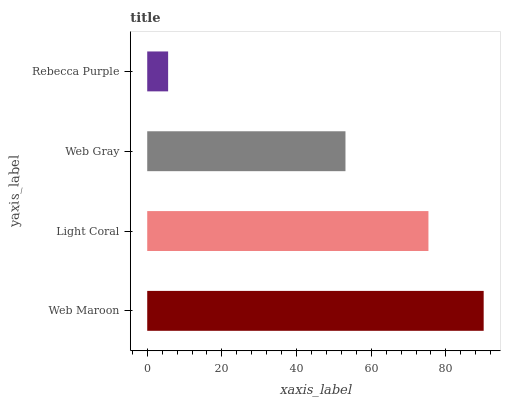Is Rebecca Purple the minimum?
Answer yes or no. Yes. Is Web Maroon the maximum?
Answer yes or no. Yes. Is Light Coral the minimum?
Answer yes or no. No. Is Light Coral the maximum?
Answer yes or no. No. Is Web Maroon greater than Light Coral?
Answer yes or no. Yes. Is Light Coral less than Web Maroon?
Answer yes or no. Yes. Is Light Coral greater than Web Maroon?
Answer yes or no. No. Is Web Maroon less than Light Coral?
Answer yes or no. No. Is Light Coral the high median?
Answer yes or no. Yes. Is Web Gray the low median?
Answer yes or no. Yes. Is Web Maroon the high median?
Answer yes or no. No. Is Light Coral the low median?
Answer yes or no. No. 